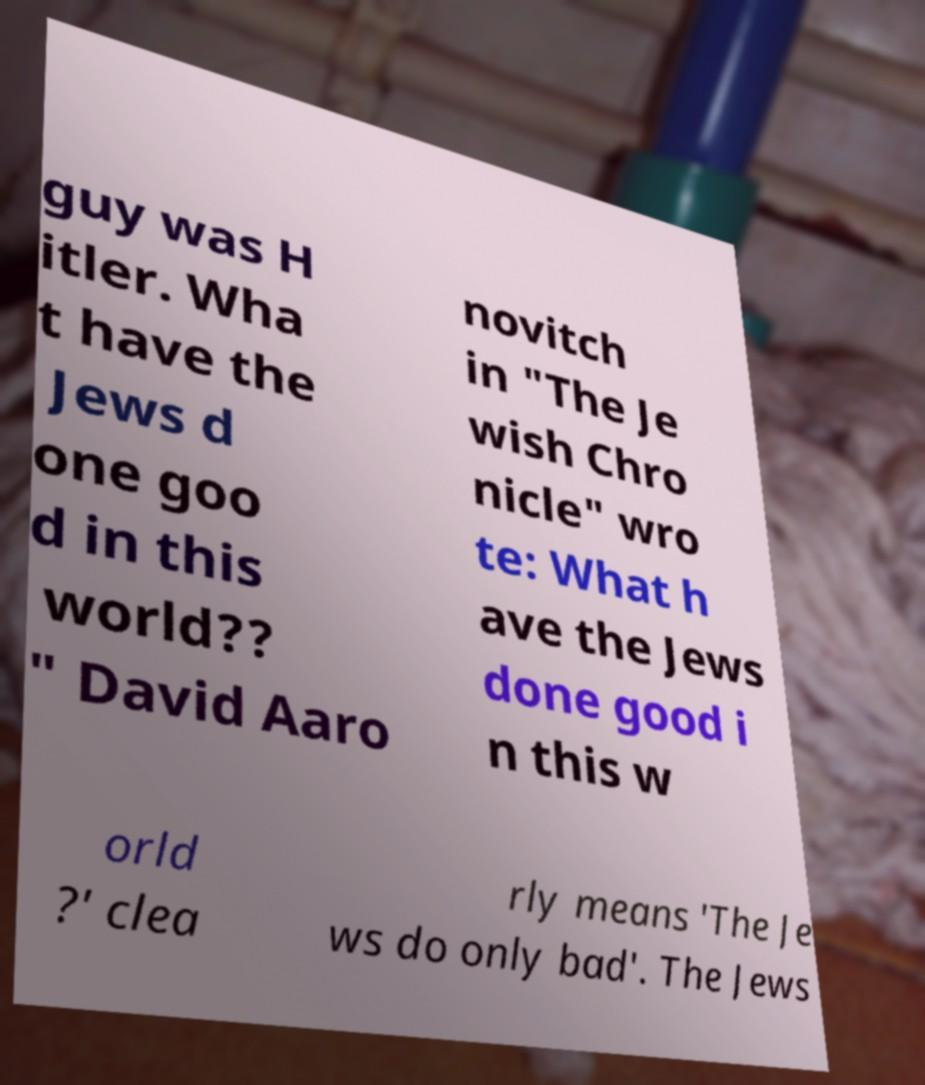What messages or text are displayed in this image? I need them in a readable, typed format. guy was H itler. Wha t have the Jews d one goo d in this world?? " David Aaro novitch in "The Je wish Chro nicle" wro te: What h ave the Jews done good i n this w orld ?' clea rly means 'The Je ws do only bad'. The Jews 